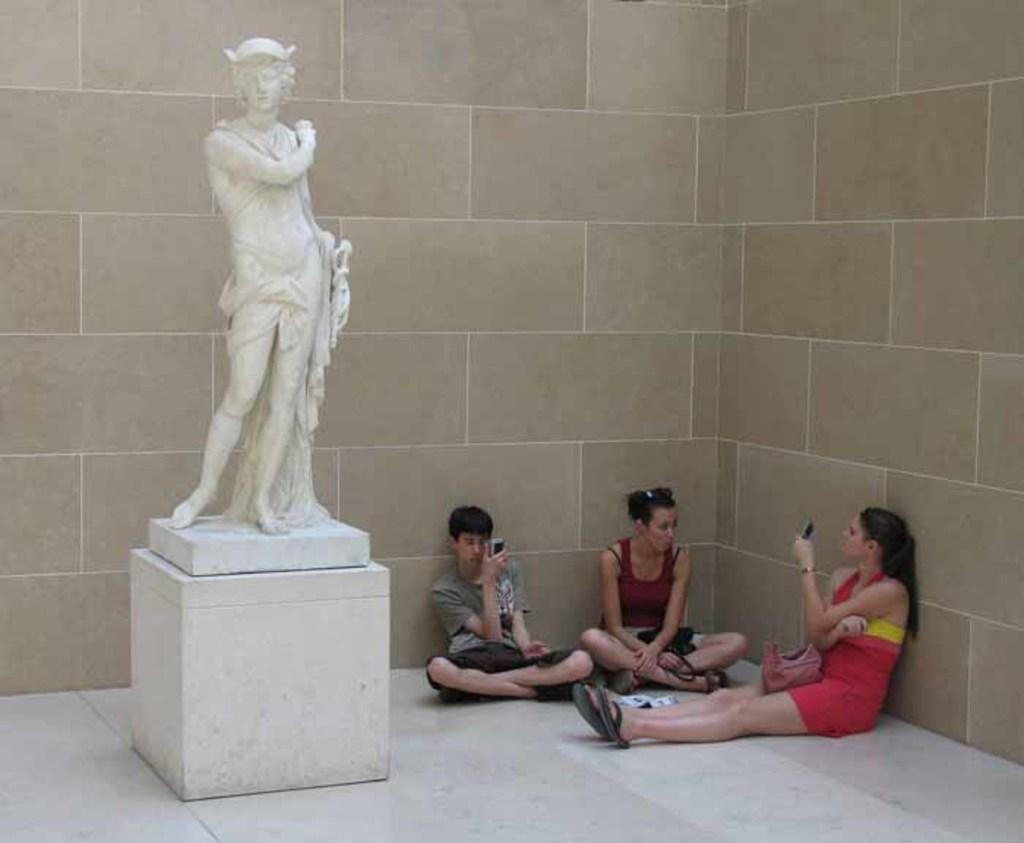Can you describe this image briefly? In this image there are three persons sitting on the floor. Image also consists of a statue and in the background there is a wall. 